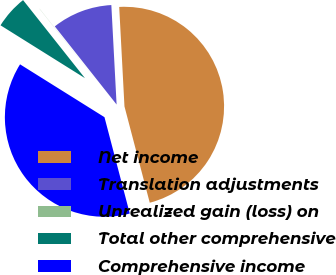<chart> <loc_0><loc_0><loc_500><loc_500><pie_chart><fcel>Net income<fcel>Translation adjustments<fcel>Unrealized gain (loss) on<fcel>Total other comprehensive<fcel>Comprehensive income<nl><fcel>46.76%<fcel>9.81%<fcel>0.02%<fcel>5.43%<fcel>37.99%<nl></chart> 